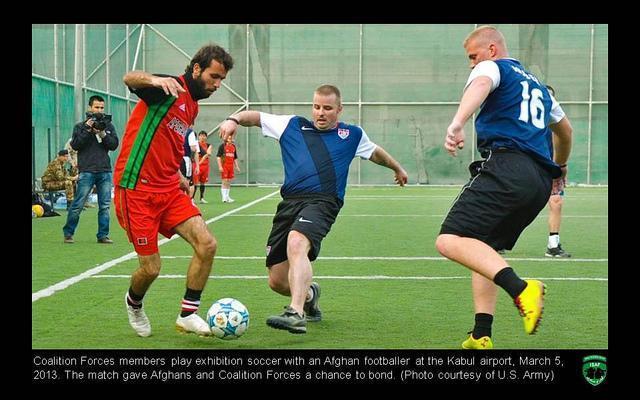How many blue shirts are there?
Give a very brief answer. 2. How many people are shown?
Give a very brief answer. 8. How many people are in the photo?
Give a very brief answer. 4. 